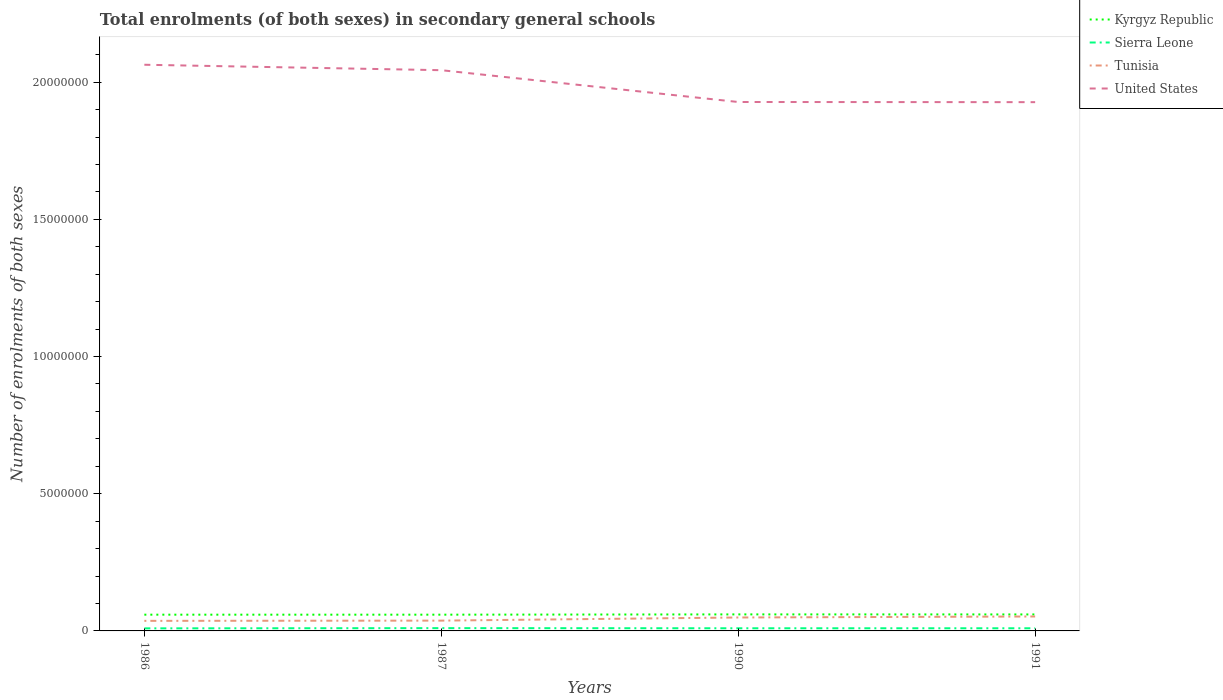Does the line corresponding to Tunisia intersect with the line corresponding to Sierra Leone?
Provide a succinct answer. No. Is the number of lines equal to the number of legend labels?
Give a very brief answer. Yes. Across all years, what is the maximum number of enrolments in secondary schools in Sierra Leone?
Provide a short and direct response. 9.35e+04. In which year was the number of enrolments in secondary schools in Sierra Leone maximum?
Your answer should be compact. 1986. What is the total number of enrolments in secondary schools in United States in the graph?
Offer a very short reply. 1.16e+06. What is the difference between the highest and the second highest number of enrolments in secondary schools in Kyrgyz Republic?
Give a very brief answer. 1.03e+04. What is the difference between the highest and the lowest number of enrolments in secondary schools in Sierra Leone?
Keep it short and to the point. 1. How many years are there in the graph?
Provide a short and direct response. 4. Does the graph contain grids?
Your answer should be very brief. No. How are the legend labels stacked?
Your answer should be very brief. Vertical. What is the title of the graph?
Keep it short and to the point. Total enrolments (of both sexes) in secondary general schools. What is the label or title of the Y-axis?
Your response must be concise. Number of enrolments of both sexes. What is the Number of enrolments of both sexes in Kyrgyz Republic in 1986?
Your answer should be very brief. 5.92e+05. What is the Number of enrolments of both sexes of Sierra Leone in 1986?
Provide a succinct answer. 9.35e+04. What is the Number of enrolments of both sexes in Tunisia in 1986?
Offer a terse response. 3.67e+05. What is the Number of enrolments of both sexes in United States in 1986?
Provide a short and direct response. 2.06e+07. What is the Number of enrolments of both sexes of Kyrgyz Republic in 1987?
Give a very brief answer. 5.92e+05. What is the Number of enrolments of both sexes in Sierra Leone in 1987?
Your answer should be compact. 1.02e+05. What is the Number of enrolments of both sexes of Tunisia in 1987?
Provide a succinct answer. 3.75e+05. What is the Number of enrolments of both sexes in United States in 1987?
Offer a very short reply. 2.04e+07. What is the Number of enrolments of both sexes of Kyrgyz Republic in 1990?
Make the answer very short. 6.02e+05. What is the Number of enrolments of both sexes in Sierra Leone in 1990?
Provide a short and direct response. 9.67e+04. What is the Number of enrolments of both sexes of Tunisia in 1990?
Your response must be concise. 4.90e+05. What is the Number of enrolments of both sexes in United States in 1990?
Provide a succinct answer. 1.93e+07. What is the Number of enrolments of both sexes of Kyrgyz Republic in 1991?
Ensure brevity in your answer.  6.01e+05. What is the Number of enrolments of both sexes of Sierra Leone in 1991?
Make the answer very short. 9.70e+04. What is the Number of enrolments of both sexes in Tunisia in 1991?
Your response must be concise. 5.26e+05. What is the Number of enrolments of both sexes in United States in 1991?
Provide a short and direct response. 1.93e+07. Across all years, what is the maximum Number of enrolments of both sexes in Kyrgyz Republic?
Your answer should be very brief. 6.02e+05. Across all years, what is the maximum Number of enrolments of both sexes of Sierra Leone?
Your response must be concise. 1.02e+05. Across all years, what is the maximum Number of enrolments of both sexes of Tunisia?
Provide a short and direct response. 5.26e+05. Across all years, what is the maximum Number of enrolments of both sexes of United States?
Ensure brevity in your answer.  2.06e+07. Across all years, what is the minimum Number of enrolments of both sexes in Kyrgyz Republic?
Make the answer very short. 5.92e+05. Across all years, what is the minimum Number of enrolments of both sexes of Sierra Leone?
Give a very brief answer. 9.35e+04. Across all years, what is the minimum Number of enrolments of both sexes of Tunisia?
Ensure brevity in your answer.  3.67e+05. Across all years, what is the minimum Number of enrolments of both sexes of United States?
Your answer should be very brief. 1.93e+07. What is the total Number of enrolments of both sexes in Kyrgyz Republic in the graph?
Keep it short and to the point. 2.39e+06. What is the total Number of enrolments of both sexes in Sierra Leone in the graph?
Keep it short and to the point. 3.89e+05. What is the total Number of enrolments of both sexes of Tunisia in the graph?
Your response must be concise. 1.76e+06. What is the total Number of enrolments of both sexes in United States in the graph?
Give a very brief answer. 7.96e+07. What is the difference between the Number of enrolments of both sexes in Kyrgyz Republic in 1986 and that in 1987?
Offer a very short reply. -300. What is the difference between the Number of enrolments of both sexes in Sierra Leone in 1986 and that in 1987?
Your answer should be compact. -8178. What is the difference between the Number of enrolments of both sexes in Tunisia in 1986 and that in 1987?
Your answer should be very brief. -8502. What is the difference between the Number of enrolments of both sexes of United States in 1986 and that in 1987?
Provide a short and direct response. 1.98e+05. What is the difference between the Number of enrolments of both sexes of Kyrgyz Republic in 1986 and that in 1990?
Make the answer very short. -1.03e+04. What is the difference between the Number of enrolments of both sexes in Sierra Leone in 1986 and that in 1990?
Your answer should be compact. -3200. What is the difference between the Number of enrolments of both sexes in Tunisia in 1986 and that in 1990?
Ensure brevity in your answer.  -1.23e+05. What is the difference between the Number of enrolments of both sexes of United States in 1986 and that in 1990?
Ensure brevity in your answer.  1.36e+06. What is the difference between the Number of enrolments of both sexes of Kyrgyz Republic in 1986 and that in 1991?
Ensure brevity in your answer.  -8700. What is the difference between the Number of enrolments of both sexes in Sierra Leone in 1986 and that in 1991?
Provide a succinct answer. -3540. What is the difference between the Number of enrolments of both sexes of Tunisia in 1986 and that in 1991?
Your answer should be compact. -1.59e+05. What is the difference between the Number of enrolments of both sexes in United States in 1986 and that in 1991?
Your answer should be very brief. 1.36e+06. What is the difference between the Number of enrolments of both sexes of Kyrgyz Republic in 1987 and that in 1990?
Your response must be concise. -10000. What is the difference between the Number of enrolments of both sexes in Sierra Leone in 1987 and that in 1990?
Offer a very short reply. 4978. What is the difference between the Number of enrolments of both sexes of Tunisia in 1987 and that in 1990?
Your response must be concise. -1.14e+05. What is the difference between the Number of enrolments of both sexes in United States in 1987 and that in 1990?
Provide a succinct answer. 1.16e+06. What is the difference between the Number of enrolments of both sexes of Kyrgyz Republic in 1987 and that in 1991?
Offer a very short reply. -8400. What is the difference between the Number of enrolments of both sexes in Sierra Leone in 1987 and that in 1991?
Ensure brevity in your answer.  4638. What is the difference between the Number of enrolments of both sexes in Tunisia in 1987 and that in 1991?
Provide a succinct answer. -1.51e+05. What is the difference between the Number of enrolments of both sexes of United States in 1987 and that in 1991?
Provide a short and direct response. 1.16e+06. What is the difference between the Number of enrolments of both sexes in Kyrgyz Republic in 1990 and that in 1991?
Provide a short and direct response. 1600. What is the difference between the Number of enrolments of both sexes in Sierra Leone in 1990 and that in 1991?
Ensure brevity in your answer.  -340. What is the difference between the Number of enrolments of both sexes in Tunisia in 1990 and that in 1991?
Your answer should be very brief. -3.65e+04. What is the difference between the Number of enrolments of both sexes of United States in 1990 and that in 1991?
Keep it short and to the point. 6000. What is the difference between the Number of enrolments of both sexes in Kyrgyz Republic in 1986 and the Number of enrolments of both sexes in Sierra Leone in 1987?
Your answer should be very brief. 4.90e+05. What is the difference between the Number of enrolments of both sexes in Kyrgyz Republic in 1986 and the Number of enrolments of both sexes in Tunisia in 1987?
Make the answer very short. 2.17e+05. What is the difference between the Number of enrolments of both sexes of Kyrgyz Republic in 1986 and the Number of enrolments of both sexes of United States in 1987?
Your answer should be very brief. -1.98e+07. What is the difference between the Number of enrolments of both sexes of Sierra Leone in 1986 and the Number of enrolments of both sexes of Tunisia in 1987?
Offer a terse response. -2.82e+05. What is the difference between the Number of enrolments of both sexes in Sierra Leone in 1986 and the Number of enrolments of both sexes in United States in 1987?
Make the answer very short. -2.03e+07. What is the difference between the Number of enrolments of both sexes of Tunisia in 1986 and the Number of enrolments of both sexes of United States in 1987?
Your answer should be very brief. -2.01e+07. What is the difference between the Number of enrolments of both sexes of Kyrgyz Republic in 1986 and the Number of enrolments of both sexes of Sierra Leone in 1990?
Provide a short and direct response. 4.95e+05. What is the difference between the Number of enrolments of both sexes in Kyrgyz Republic in 1986 and the Number of enrolments of both sexes in Tunisia in 1990?
Your answer should be very brief. 1.02e+05. What is the difference between the Number of enrolments of both sexes in Kyrgyz Republic in 1986 and the Number of enrolments of both sexes in United States in 1990?
Offer a very short reply. -1.87e+07. What is the difference between the Number of enrolments of both sexes in Sierra Leone in 1986 and the Number of enrolments of both sexes in Tunisia in 1990?
Offer a terse response. -3.96e+05. What is the difference between the Number of enrolments of both sexes in Sierra Leone in 1986 and the Number of enrolments of both sexes in United States in 1990?
Your response must be concise. -1.92e+07. What is the difference between the Number of enrolments of both sexes in Tunisia in 1986 and the Number of enrolments of both sexes in United States in 1990?
Your answer should be compact. -1.89e+07. What is the difference between the Number of enrolments of both sexes in Kyrgyz Republic in 1986 and the Number of enrolments of both sexes in Sierra Leone in 1991?
Provide a succinct answer. 4.95e+05. What is the difference between the Number of enrolments of both sexes in Kyrgyz Republic in 1986 and the Number of enrolments of both sexes in Tunisia in 1991?
Your response must be concise. 6.58e+04. What is the difference between the Number of enrolments of both sexes in Kyrgyz Republic in 1986 and the Number of enrolments of both sexes in United States in 1991?
Give a very brief answer. -1.87e+07. What is the difference between the Number of enrolments of both sexes in Sierra Leone in 1986 and the Number of enrolments of both sexes in Tunisia in 1991?
Make the answer very short. -4.33e+05. What is the difference between the Number of enrolments of both sexes in Sierra Leone in 1986 and the Number of enrolments of both sexes in United States in 1991?
Make the answer very short. -1.92e+07. What is the difference between the Number of enrolments of both sexes of Tunisia in 1986 and the Number of enrolments of both sexes of United States in 1991?
Make the answer very short. -1.89e+07. What is the difference between the Number of enrolments of both sexes of Kyrgyz Republic in 1987 and the Number of enrolments of both sexes of Sierra Leone in 1990?
Ensure brevity in your answer.  4.96e+05. What is the difference between the Number of enrolments of both sexes of Kyrgyz Republic in 1987 and the Number of enrolments of both sexes of Tunisia in 1990?
Give a very brief answer. 1.03e+05. What is the difference between the Number of enrolments of both sexes in Kyrgyz Republic in 1987 and the Number of enrolments of both sexes in United States in 1990?
Keep it short and to the point. -1.87e+07. What is the difference between the Number of enrolments of both sexes in Sierra Leone in 1987 and the Number of enrolments of both sexes in Tunisia in 1990?
Give a very brief answer. -3.88e+05. What is the difference between the Number of enrolments of both sexes in Sierra Leone in 1987 and the Number of enrolments of both sexes in United States in 1990?
Offer a very short reply. -1.92e+07. What is the difference between the Number of enrolments of both sexes of Tunisia in 1987 and the Number of enrolments of both sexes of United States in 1990?
Your response must be concise. -1.89e+07. What is the difference between the Number of enrolments of both sexes of Kyrgyz Republic in 1987 and the Number of enrolments of both sexes of Sierra Leone in 1991?
Your answer should be very brief. 4.95e+05. What is the difference between the Number of enrolments of both sexes of Kyrgyz Republic in 1987 and the Number of enrolments of both sexes of Tunisia in 1991?
Your response must be concise. 6.61e+04. What is the difference between the Number of enrolments of both sexes in Kyrgyz Republic in 1987 and the Number of enrolments of both sexes in United States in 1991?
Your response must be concise. -1.87e+07. What is the difference between the Number of enrolments of both sexes in Sierra Leone in 1987 and the Number of enrolments of both sexes in Tunisia in 1991?
Keep it short and to the point. -4.25e+05. What is the difference between the Number of enrolments of both sexes of Sierra Leone in 1987 and the Number of enrolments of both sexes of United States in 1991?
Offer a terse response. -1.92e+07. What is the difference between the Number of enrolments of both sexes of Tunisia in 1987 and the Number of enrolments of both sexes of United States in 1991?
Give a very brief answer. -1.89e+07. What is the difference between the Number of enrolments of both sexes in Kyrgyz Republic in 1990 and the Number of enrolments of both sexes in Sierra Leone in 1991?
Provide a short and direct response. 5.05e+05. What is the difference between the Number of enrolments of both sexes of Kyrgyz Republic in 1990 and the Number of enrolments of both sexes of Tunisia in 1991?
Keep it short and to the point. 7.61e+04. What is the difference between the Number of enrolments of both sexes in Kyrgyz Republic in 1990 and the Number of enrolments of both sexes in United States in 1991?
Your answer should be compact. -1.87e+07. What is the difference between the Number of enrolments of both sexes of Sierra Leone in 1990 and the Number of enrolments of both sexes of Tunisia in 1991?
Give a very brief answer. -4.30e+05. What is the difference between the Number of enrolments of both sexes in Sierra Leone in 1990 and the Number of enrolments of both sexes in United States in 1991?
Make the answer very short. -1.92e+07. What is the difference between the Number of enrolments of both sexes of Tunisia in 1990 and the Number of enrolments of both sexes of United States in 1991?
Your response must be concise. -1.88e+07. What is the average Number of enrolments of both sexes of Kyrgyz Republic per year?
Give a very brief answer. 5.97e+05. What is the average Number of enrolments of both sexes of Sierra Leone per year?
Provide a short and direct response. 9.72e+04. What is the average Number of enrolments of both sexes of Tunisia per year?
Give a very brief answer. 4.40e+05. What is the average Number of enrolments of both sexes of United States per year?
Provide a succinct answer. 1.99e+07. In the year 1986, what is the difference between the Number of enrolments of both sexes in Kyrgyz Republic and Number of enrolments of both sexes in Sierra Leone?
Ensure brevity in your answer.  4.98e+05. In the year 1986, what is the difference between the Number of enrolments of both sexes in Kyrgyz Republic and Number of enrolments of both sexes in Tunisia?
Your answer should be very brief. 2.25e+05. In the year 1986, what is the difference between the Number of enrolments of both sexes in Kyrgyz Republic and Number of enrolments of both sexes in United States?
Offer a terse response. -2.00e+07. In the year 1986, what is the difference between the Number of enrolments of both sexes in Sierra Leone and Number of enrolments of both sexes in Tunisia?
Offer a very short reply. -2.73e+05. In the year 1986, what is the difference between the Number of enrolments of both sexes in Sierra Leone and Number of enrolments of both sexes in United States?
Your answer should be very brief. -2.05e+07. In the year 1986, what is the difference between the Number of enrolments of both sexes of Tunisia and Number of enrolments of both sexes of United States?
Make the answer very short. -2.03e+07. In the year 1987, what is the difference between the Number of enrolments of both sexes in Kyrgyz Republic and Number of enrolments of both sexes in Sierra Leone?
Your response must be concise. 4.91e+05. In the year 1987, what is the difference between the Number of enrolments of both sexes of Kyrgyz Republic and Number of enrolments of both sexes of Tunisia?
Your answer should be very brief. 2.17e+05. In the year 1987, what is the difference between the Number of enrolments of both sexes in Kyrgyz Republic and Number of enrolments of both sexes in United States?
Provide a succinct answer. -1.98e+07. In the year 1987, what is the difference between the Number of enrolments of both sexes of Sierra Leone and Number of enrolments of both sexes of Tunisia?
Provide a short and direct response. -2.74e+05. In the year 1987, what is the difference between the Number of enrolments of both sexes of Sierra Leone and Number of enrolments of both sexes of United States?
Your answer should be very brief. -2.03e+07. In the year 1987, what is the difference between the Number of enrolments of both sexes of Tunisia and Number of enrolments of both sexes of United States?
Ensure brevity in your answer.  -2.01e+07. In the year 1990, what is the difference between the Number of enrolments of both sexes of Kyrgyz Republic and Number of enrolments of both sexes of Sierra Leone?
Your response must be concise. 5.06e+05. In the year 1990, what is the difference between the Number of enrolments of both sexes in Kyrgyz Republic and Number of enrolments of both sexes in Tunisia?
Your answer should be compact. 1.13e+05. In the year 1990, what is the difference between the Number of enrolments of both sexes in Kyrgyz Republic and Number of enrolments of both sexes in United States?
Offer a terse response. -1.87e+07. In the year 1990, what is the difference between the Number of enrolments of both sexes in Sierra Leone and Number of enrolments of both sexes in Tunisia?
Ensure brevity in your answer.  -3.93e+05. In the year 1990, what is the difference between the Number of enrolments of both sexes of Sierra Leone and Number of enrolments of both sexes of United States?
Ensure brevity in your answer.  -1.92e+07. In the year 1990, what is the difference between the Number of enrolments of both sexes in Tunisia and Number of enrolments of both sexes in United States?
Your answer should be compact. -1.88e+07. In the year 1991, what is the difference between the Number of enrolments of both sexes in Kyrgyz Republic and Number of enrolments of both sexes in Sierra Leone?
Provide a succinct answer. 5.04e+05. In the year 1991, what is the difference between the Number of enrolments of both sexes in Kyrgyz Republic and Number of enrolments of both sexes in Tunisia?
Ensure brevity in your answer.  7.45e+04. In the year 1991, what is the difference between the Number of enrolments of both sexes in Kyrgyz Republic and Number of enrolments of both sexes in United States?
Provide a succinct answer. -1.87e+07. In the year 1991, what is the difference between the Number of enrolments of both sexes of Sierra Leone and Number of enrolments of both sexes of Tunisia?
Your answer should be compact. -4.29e+05. In the year 1991, what is the difference between the Number of enrolments of both sexes in Sierra Leone and Number of enrolments of both sexes in United States?
Offer a very short reply. -1.92e+07. In the year 1991, what is the difference between the Number of enrolments of both sexes of Tunisia and Number of enrolments of both sexes of United States?
Provide a succinct answer. -1.87e+07. What is the ratio of the Number of enrolments of both sexes in Kyrgyz Republic in 1986 to that in 1987?
Offer a terse response. 1. What is the ratio of the Number of enrolments of both sexes of Sierra Leone in 1986 to that in 1987?
Offer a terse response. 0.92. What is the ratio of the Number of enrolments of both sexes in Tunisia in 1986 to that in 1987?
Provide a succinct answer. 0.98. What is the ratio of the Number of enrolments of both sexes of United States in 1986 to that in 1987?
Your answer should be very brief. 1.01. What is the ratio of the Number of enrolments of both sexes in Kyrgyz Republic in 1986 to that in 1990?
Ensure brevity in your answer.  0.98. What is the ratio of the Number of enrolments of both sexes in Sierra Leone in 1986 to that in 1990?
Offer a terse response. 0.97. What is the ratio of the Number of enrolments of both sexes of Tunisia in 1986 to that in 1990?
Your response must be concise. 0.75. What is the ratio of the Number of enrolments of both sexes in United States in 1986 to that in 1990?
Your response must be concise. 1.07. What is the ratio of the Number of enrolments of both sexes in Kyrgyz Republic in 1986 to that in 1991?
Offer a terse response. 0.99. What is the ratio of the Number of enrolments of both sexes in Sierra Leone in 1986 to that in 1991?
Provide a succinct answer. 0.96. What is the ratio of the Number of enrolments of both sexes of Tunisia in 1986 to that in 1991?
Make the answer very short. 0.7. What is the ratio of the Number of enrolments of both sexes in United States in 1986 to that in 1991?
Keep it short and to the point. 1.07. What is the ratio of the Number of enrolments of both sexes in Kyrgyz Republic in 1987 to that in 1990?
Keep it short and to the point. 0.98. What is the ratio of the Number of enrolments of both sexes of Sierra Leone in 1987 to that in 1990?
Keep it short and to the point. 1.05. What is the ratio of the Number of enrolments of both sexes of Tunisia in 1987 to that in 1990?
Your answer should be compact. 0.77. What is the ratio of the Number of enrolments of both sexes of United States in 1987 to that in 1990?
Keep it short and to the point. 1.06. What is the ratio of the Number of enrolments of both sexes in Sierra Leone in 1987 to that in 1991?
Offer a very short reply. 1.05. What is the ratio of the Number of enrolments of both sexes of Tunisia in 1987 to that in 1991?
Provide a short and direct response. 0.71. What is the ratio of the Number of enrolments of both sexes in United States in 1987 to that in 1991?
Your answer should be very brief. 1.06. What is the ratio of the Number of enrolments of both sexes of Kyrgyz Republic in 1990 to that in 1991?
Make the answer very short. 1. What is the ratio of the Number of enrolments of both sexes of Tunisia in 1990 to that in 1991?
Provide a short and direct response. 0.93. What is the ratio of the Number of enrolments of both sexes in United States in 1990 to that in 1991?
Make the answer very short. 1. What is the difference between the highest and the second highest Number of enrolments of both sexes of Kyrgyz Republic?
Offer a very short reply. 1600. What is the difference between the highest and the second highest Number of enrolments of both sexes in Sierra Leone?
Offer a very short reply. 4638. What is the difference between the highest and the second highest Number of enrolments of both sexes in Tunisia?
Your answer should be compact. 3.65e+04. What is the difference between the highest and the second highest Number of enrolments of both sexes in United States?
Your answer should be very brief. 1.98e+05. What is the difference between the highest and the lowest Number of enrolments of both sexes of Kyrgyz Republic?
Your answer should be very brief. 1.03e+04. What is the difference between the highest and the lowest Number of enrolments of both sexes in Sierra Leone?
Ensure brevity in your answer.  8178. What is the difference between the highest and the lowest Number of enrolments of both sexes in Tunisia?
Provide a succinct answer. 1.59e+05. What is the difference between the highest and the lowest Number of enrolments of both sexes in United States?
Your answer should be compact. 1.36e+06. 